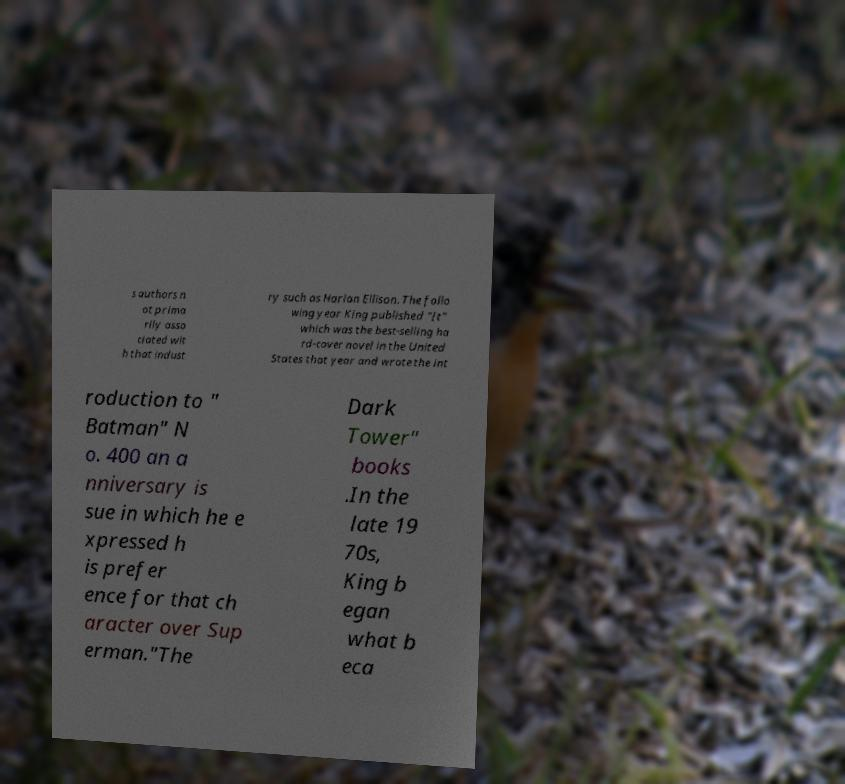Can you accurately transcribe the text from the provided image for me? s authors n ot prima rily asso ciated wit h that indust ry such as Harlan Ellison. The follo wing year King published "It" which was the best-selling ha rd-cover novel in the United States that year and wrote the int roduction to " Batman" N o. 400 an a nniversary is sue in which he e xpressed h is prefer ence for that ch aracter over Sup erman."The Dark Tower" books .In the late 19 70s, King b egan what b eca 